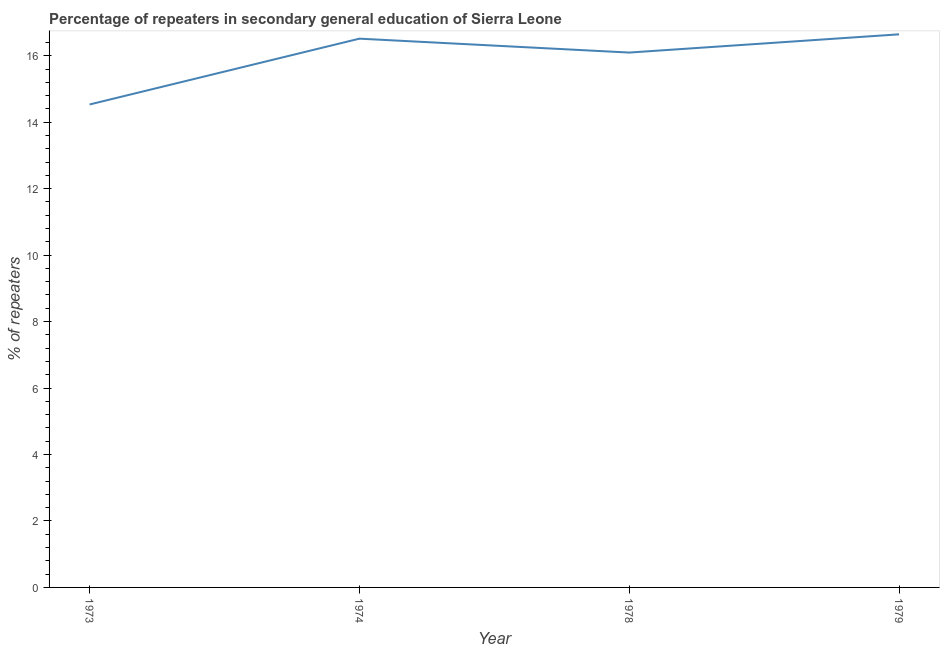What is the percentage of repeaters in 1979?
Your answer should be very brief. 16.64. Across all years, what is the maximum percentage of repeaters?
Keep it short and to the point. 16.64. Across all years, what is the minimum percentage of repeaters?
Provide a succinct answer. 14.53. In which year was the percentage of repeaters maximum?
Keep it short and to the point. 1979. In which year was the percentage of repeaters minimum?
Make the answer very short. 1973. What is the sum of the percentage of repeaters?
Make the answer very short. 63.79. What is the difference between the percentage of repeaters in 1973 and 1978?
Give a very brief answer. -1.56. What is the average percentage of repeaters per year?
Make the answer very short. 15.95. What is the median percentage of repeaters?
Provide a succinct answer. 16.3. What is the ratio of the percentage of repeaters in 1974 to that in 1978?
Keep it short and to the point. 1.03. What is the difference between the highest and the second highest percentage of repeaters?
Your response must be concise. 0.13. What is the difference between the highest and the lowest percentage of repeaters?
Offer a very short reply. 2.11. How many years are there in the graph?
Make the answer very short. 4. What is the difference between two consecutive major ticks on the Y-axis?
Provide a succinct answer. 2. Are the values on the major ticks of Y-axis written in scientific E-notation?
Provide a short and direct response. No. Does the graph contain any zero values?
Offer a terse response. No. Does the graph contain grids?
Your answer should be compact. No. What is the title of the graph?
Give a very brief answer. Percentage of repeaters in secondary general education of Sierra Leone. What is the label or title of the X-axis?
Keep it short and to the point. Year. What is the label or title of the Y-axis?
Ensure brevity in your answer.  % of repeaters. What is the % of repeaters of 1973?
Your answer should be very brief. 14.53. What is the % of repeaters in 1974?
Give a very brief answer. 16.51. What is the % of repeaters of 1978?
Offer a very short reply. 16.1. What is the % of repeaters in 1979?
Keep it short and to the point. 16.64. What is the difference between the % of repeaters in 1973 and 1974?
Keep it short and to the point. -1.98. What is the difference between the % of repeaters in 1973 and 1978?
Provide a succinct answer. -1.56. What is the difference between the % of repeaters in 1973 and 1979?
Offer a very short reply. -2.11. What is the difference between the % of repeaters in 1974 and 1978?
Your answer should be compact. 0.42. What is the difference between the % of repeaters in 1974 and 1979?
Provide a short and direct response. -0.13. What is the difference between the % of repeaters in 1978 and 1979?
Make the answer very short. -0.55. What is the ratio of the % of repeaters in 1973 to that in 1978?
Your answer should be very brief. 0.9. What is the ratio of the % of repeaters in 1973 to that in 1979?
Offer a very short reply. 0.87. What is the ratio of the % of repeaters in 1974 to that in 1979?
Offer a terse response. 0.99. What is the ratio of the % of repeaters in 1978 to that in 1979?
Make the answer very short. 0.97. 